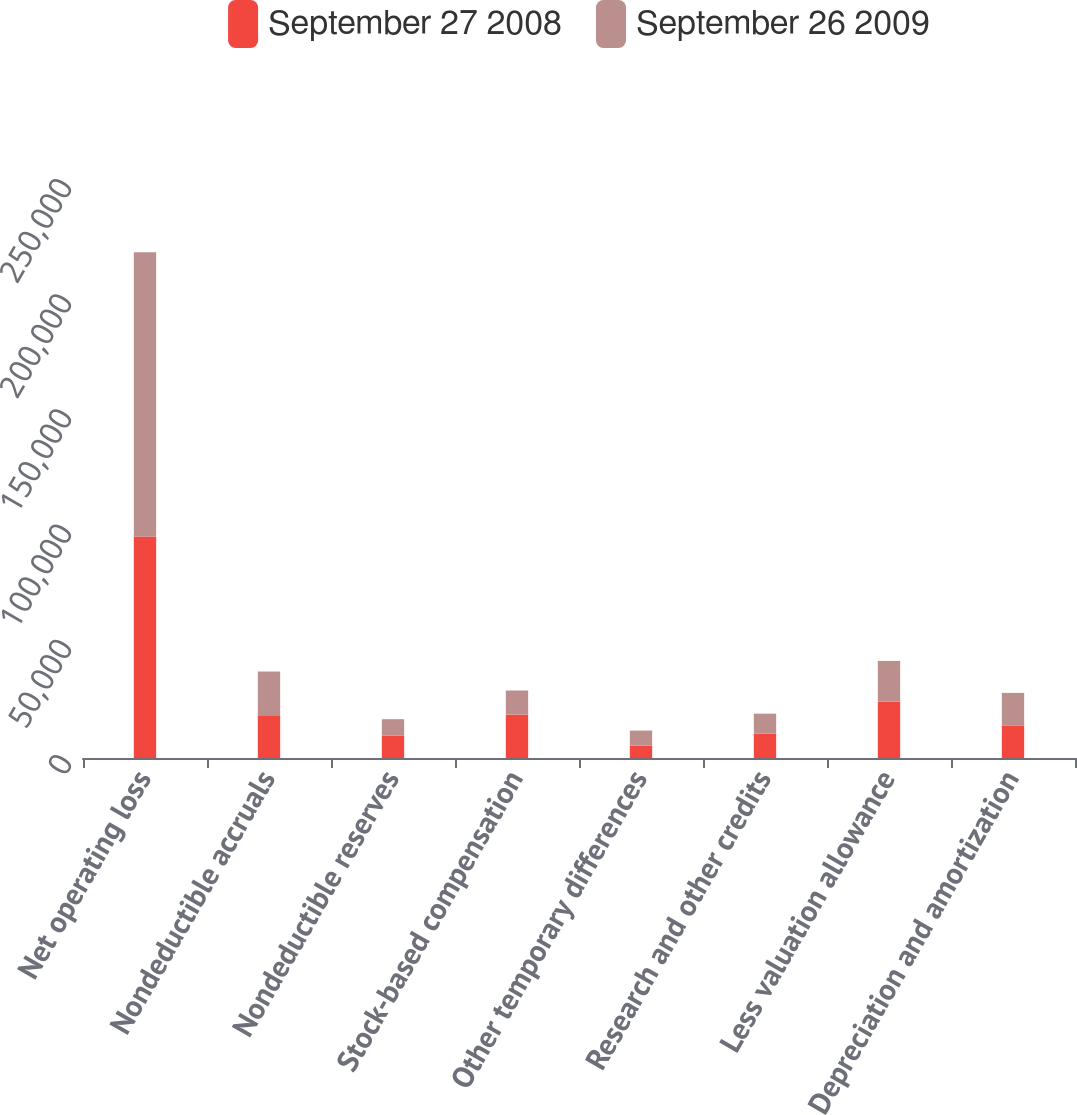<chart> <loc_0><loc_0><loc_500><loc_500><stacked_bar_chart><ecel><fcel>Net operating loss<fcel>Nondeductible accruals<fcel>Nondeductible reserves<fcel>Stock-based compensation<fcel>Other temporary differences<fcel>Research and other credits<fcel>Less valuation allowance<fcel>Depreciation and amortization<nl><fcel>September 27 2008<fcel>96170<fcel>18533<fcel>9773<fcel>18926<fcel>5421<fcel>10550<fcel>24424<fcel>14130<nl><fcel>September 26 2009<fcel>123377<fcel>19038<fcel>7068<fcel>10373<fcel>6486<fcel>8698<fcel>17710<fcel>14130<nl></chart> 